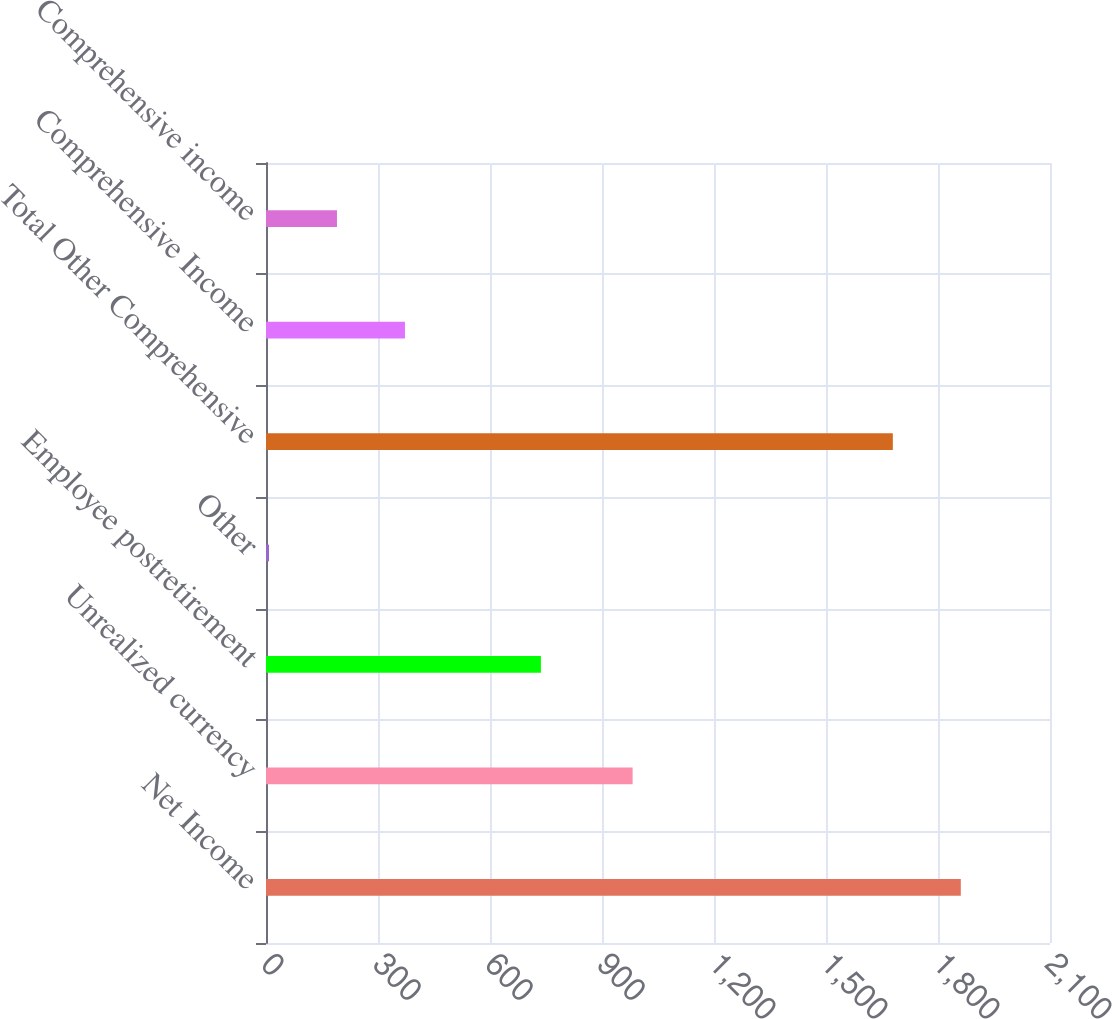<chart> <loc_0><loc_0><loc_500><loc_500><bar_chart><fcel>Net Income<fcel>Unrealized currency<fcel>Employee postretirement<fcel>Other<fcel>Total Other Comprehensive<fcel>Comprehensive Income<fcel>Comprehensive income<nl><fcel>1861.1<fcel>982<fcel>736.4<fcel>8<fcel>1679<fcel>372.2<fcel>190.1<nl></chart> 